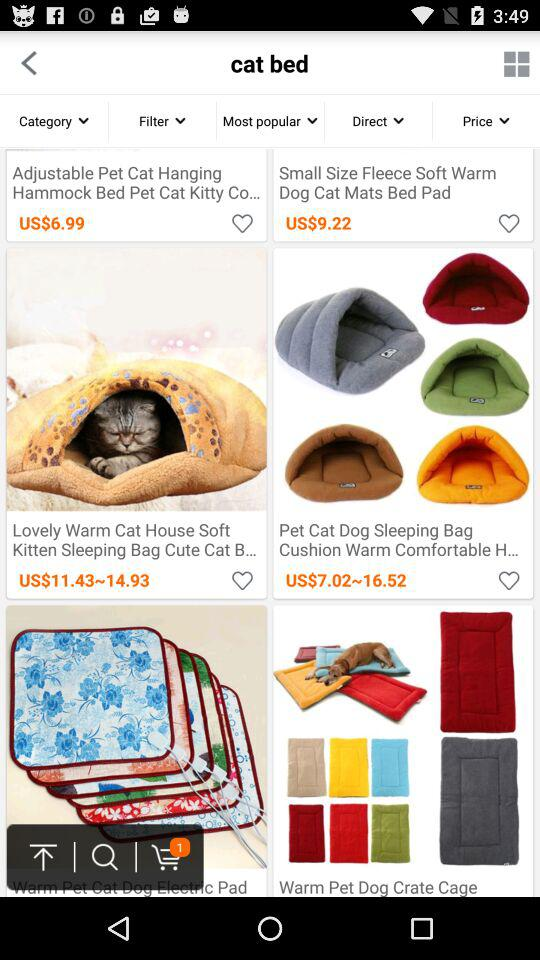What is the price of "Small Size Fleece Soft Warm Dog Cat Mats Bed Pad"? The price is $9.22. 